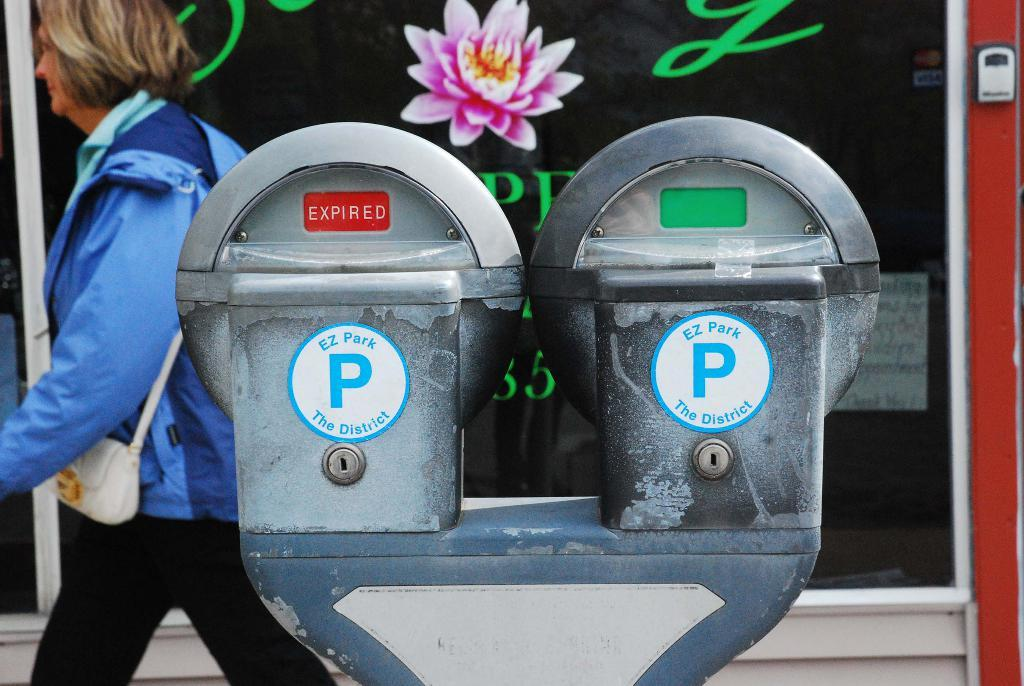<image>
Describe the image concisely. A woman is walking by two parking meters that say EZ Park The District. 